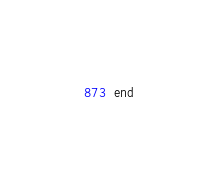<code> <loc_0><loc_0><loc_500><loc_500><_Ruby_>end
</code> 